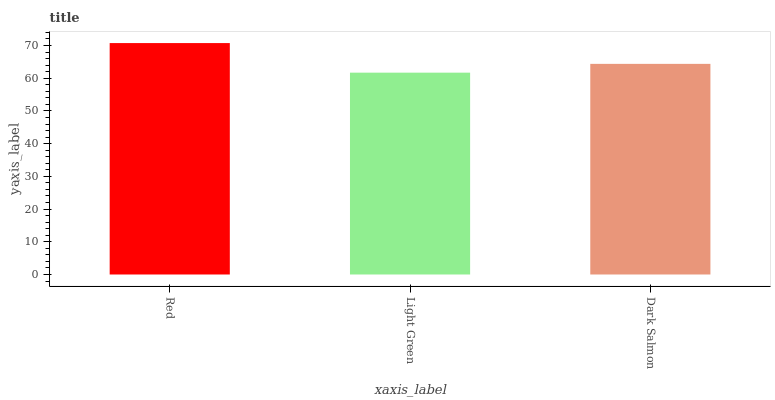Is Light Green the minimum?
Answer yes or no. Yes. Is Red the maximum?
Answer yes or no. Yes. Is Dark Salmon the minimum?
Answer yes or no. No. Is Dark Salmon the maximum?
Answer yes or no. No. Is Dark Salmon greater than Light Green?
Answer yes or no. Yes. Is Light Green less than Dark Salmon?
Answer yes or no. Yes. Is Light Green greater than Dark Salmon?
Answer yes or no. No. Is Dark Salmon less than Light Green?
Answer yes or no. No. Is Dark Salmon the high median?
Answer yes or no. Yes. Is Dark Salmon the low median?
Answer yes or no. Yes. Is Light Green the high median?
Answer yes or no. No. Is Red the low median?
Answer yes or no. No. 